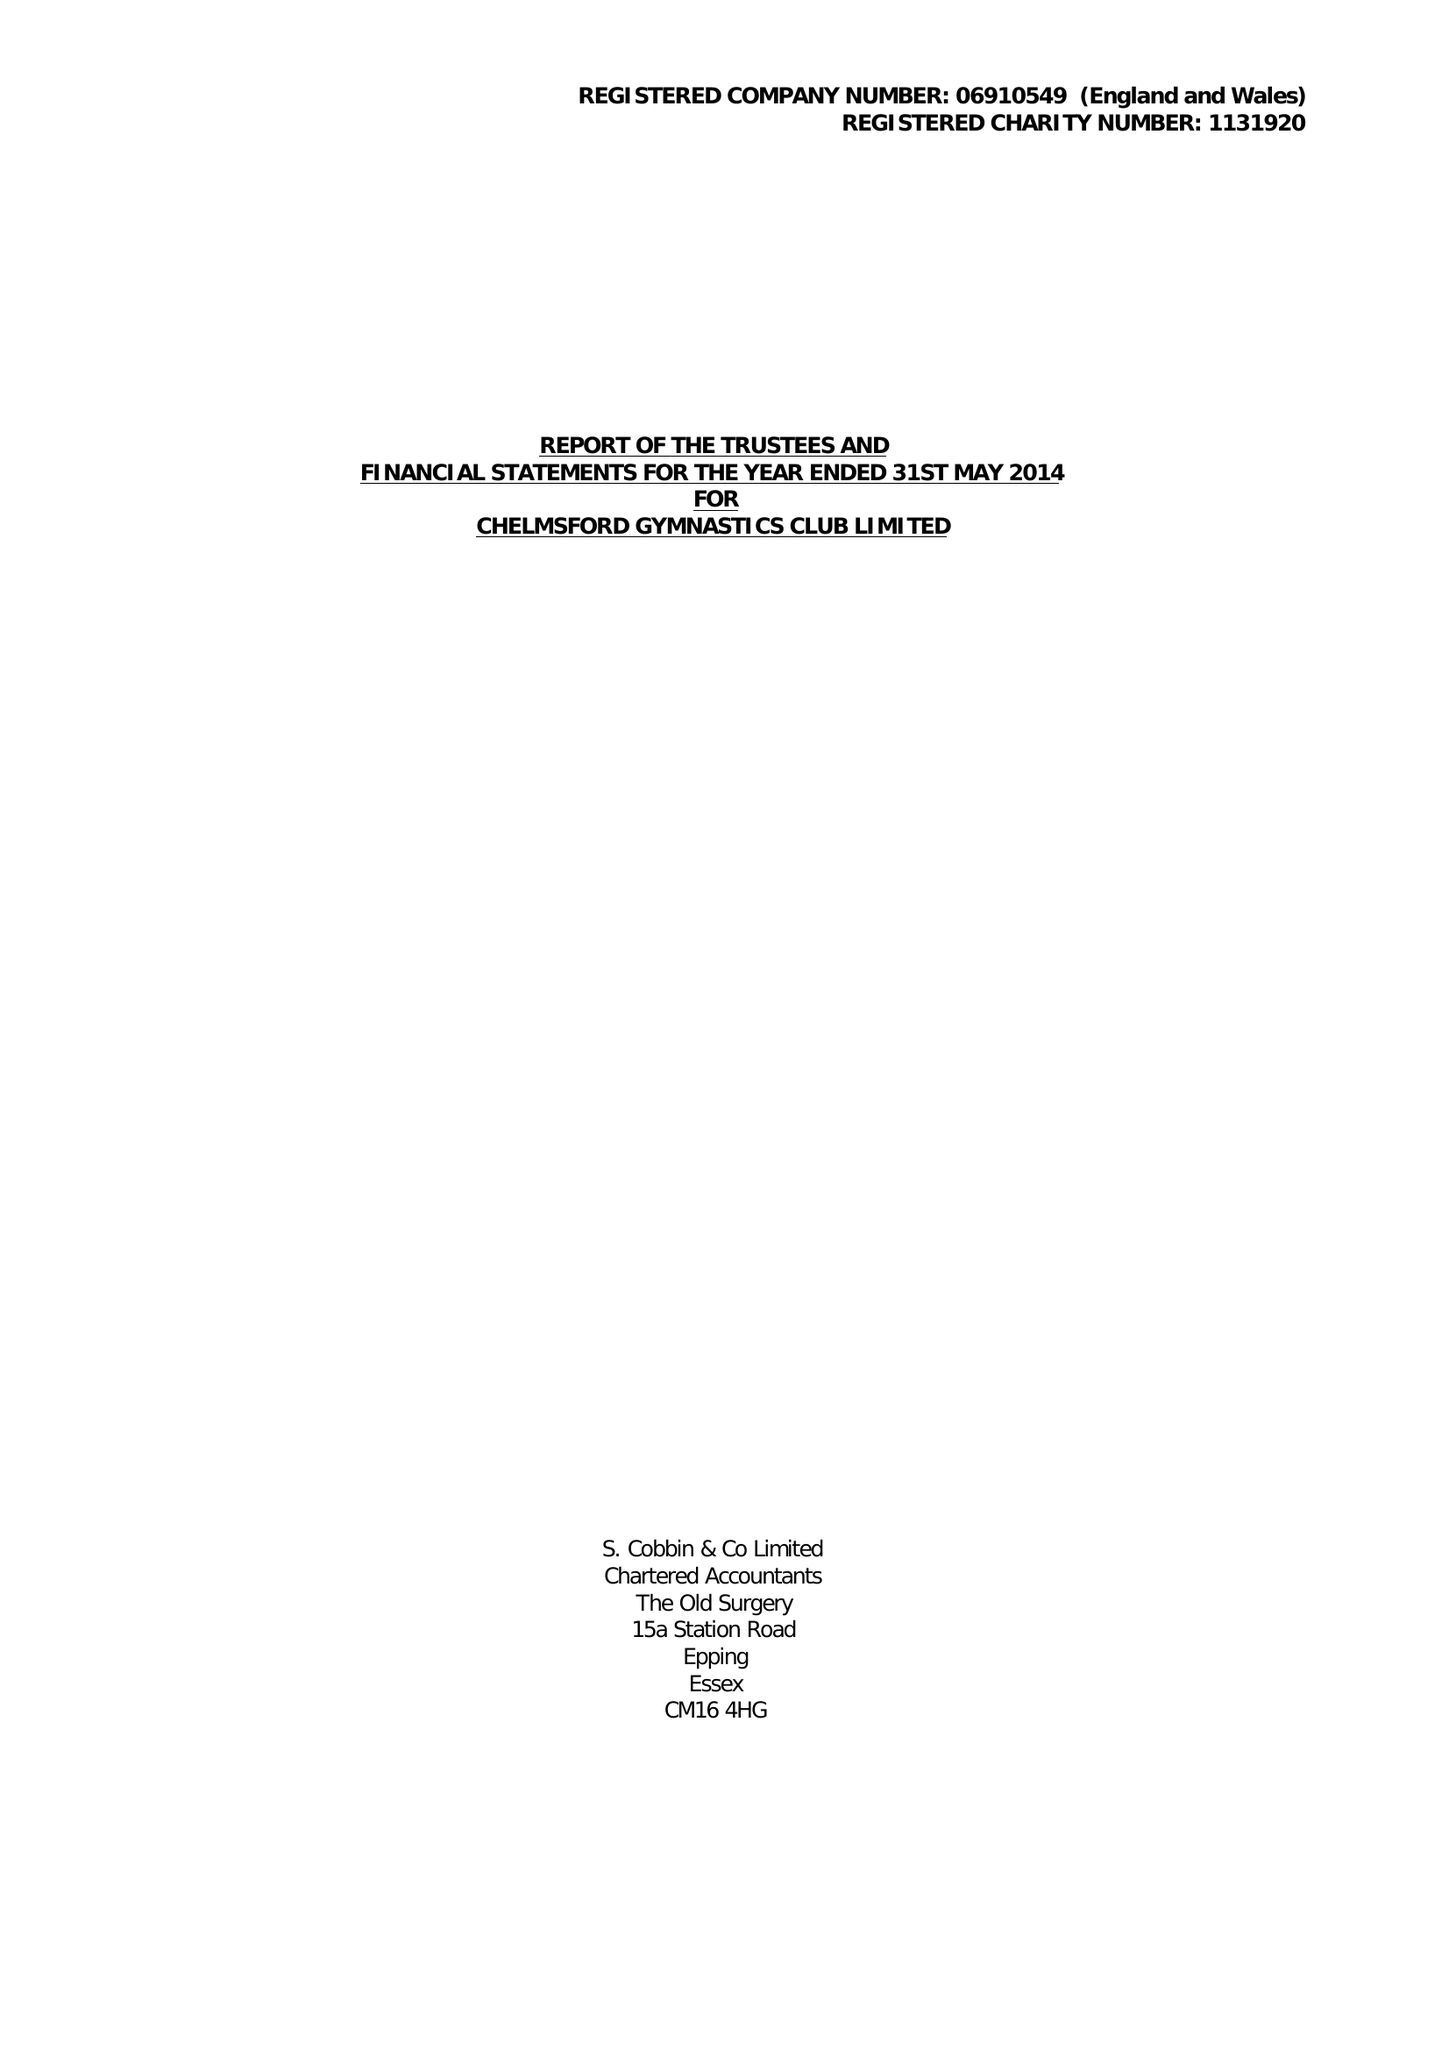What is the value for the charity_number?
Answer the question using a single word or phrase. 1131920 